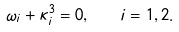<formula> <loc_0><loc_0><loc_500><loc_500>\omega _ { i } + \kappa _ { i } ^ { 3 } = 0 , \quad i = 1 , 2 .</formula> 